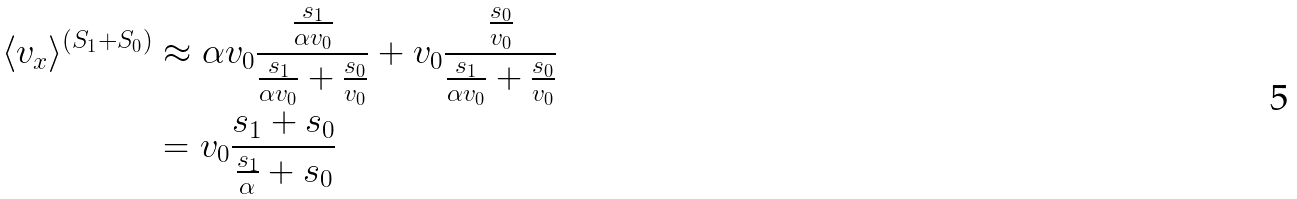Convert formula to latex. <formula><loc_0><loc_0><loc_500><loc_500>\langle v _ { x } \rangle ^ { ( S _ { 1 } + S _ { 0 } ) } & \approx \alpha v _ { 0 } \frac { \frac { s _ { 1 } } { \alpha v _ { 0 } } } { \frac { s _ { 1 } } { \alpha v _ { 0 } } + \frac { s _ { 0 } } { v _ { 0 } } } + v _ { 0 } \frac { \frac { s _ { 0 } } { v _ { 0 } } } { \frac { s _ { 1 } } { \alpha v _ { 0 } } + \frac { s _ { 0 } } { v _ { 0 } } } \\ & = v _ { 0 } \frac { s _ { 1 } + s _ { 0 } } { \frac { s _ { 1 } } { \alpha } + s _ { 0 } }</formula> 